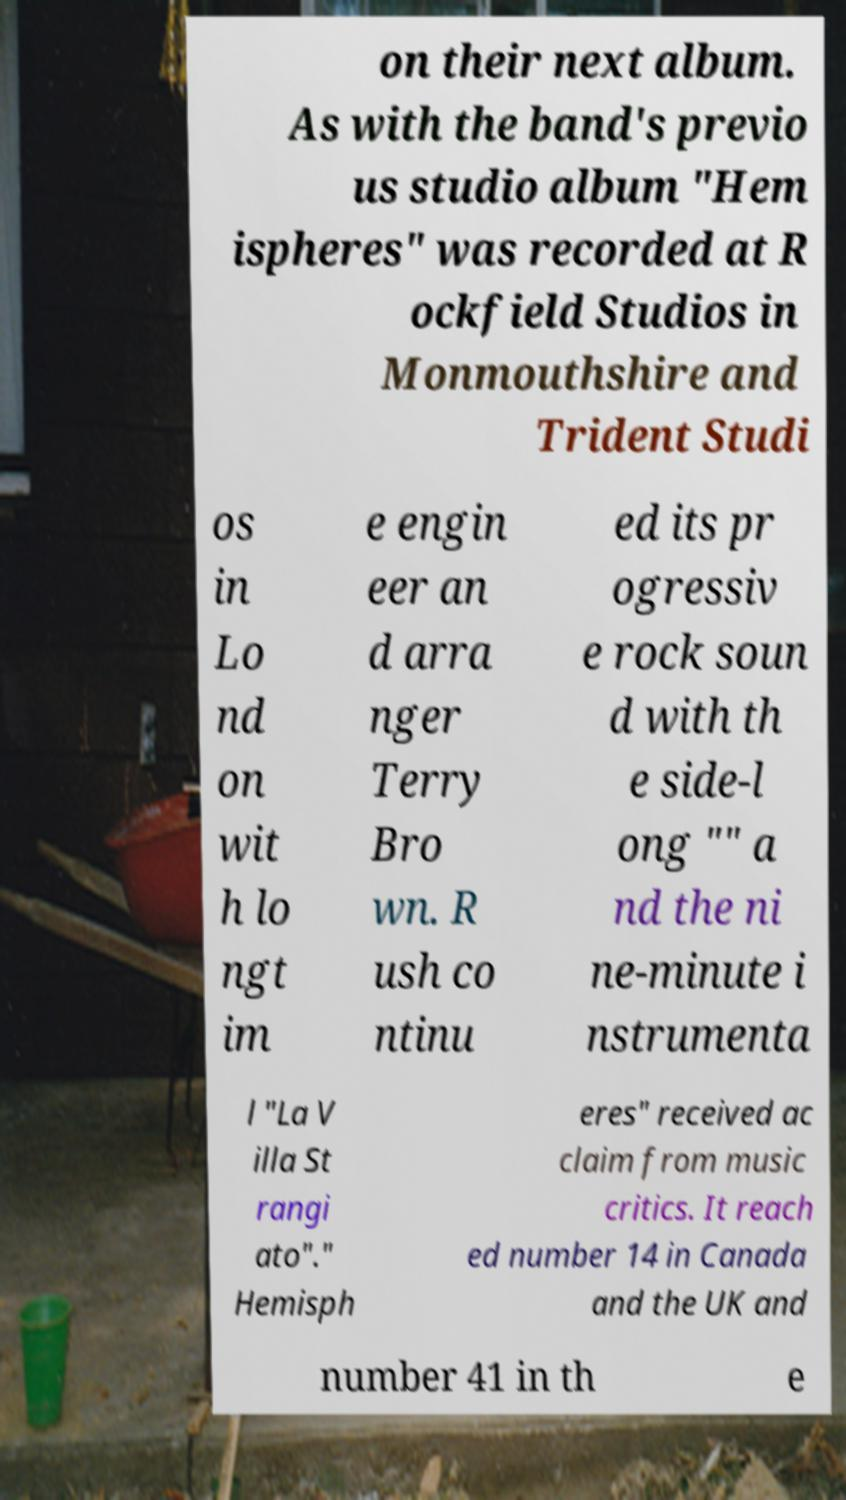Please read and relay the text visible in this image. What does it say? on their next album. As with the band's previo us studio album "Hem ispheres" was recorded at R ockfield Studios in Monmouthshire and Trident Studi os in Lo nd on wit h lo ngt im e engin eer an d arra nger Terry Bro wn. R ush co ntinu ed its pr ogressiv e rock soun d with th e side-l ong "" a nd the ni ne-minute i nstrumenta l "La V illa St rangi ato"." Hemisph eres" received ac claim from music critics. It reach ed number 14 in Canada and the UK and number 41 in th e 